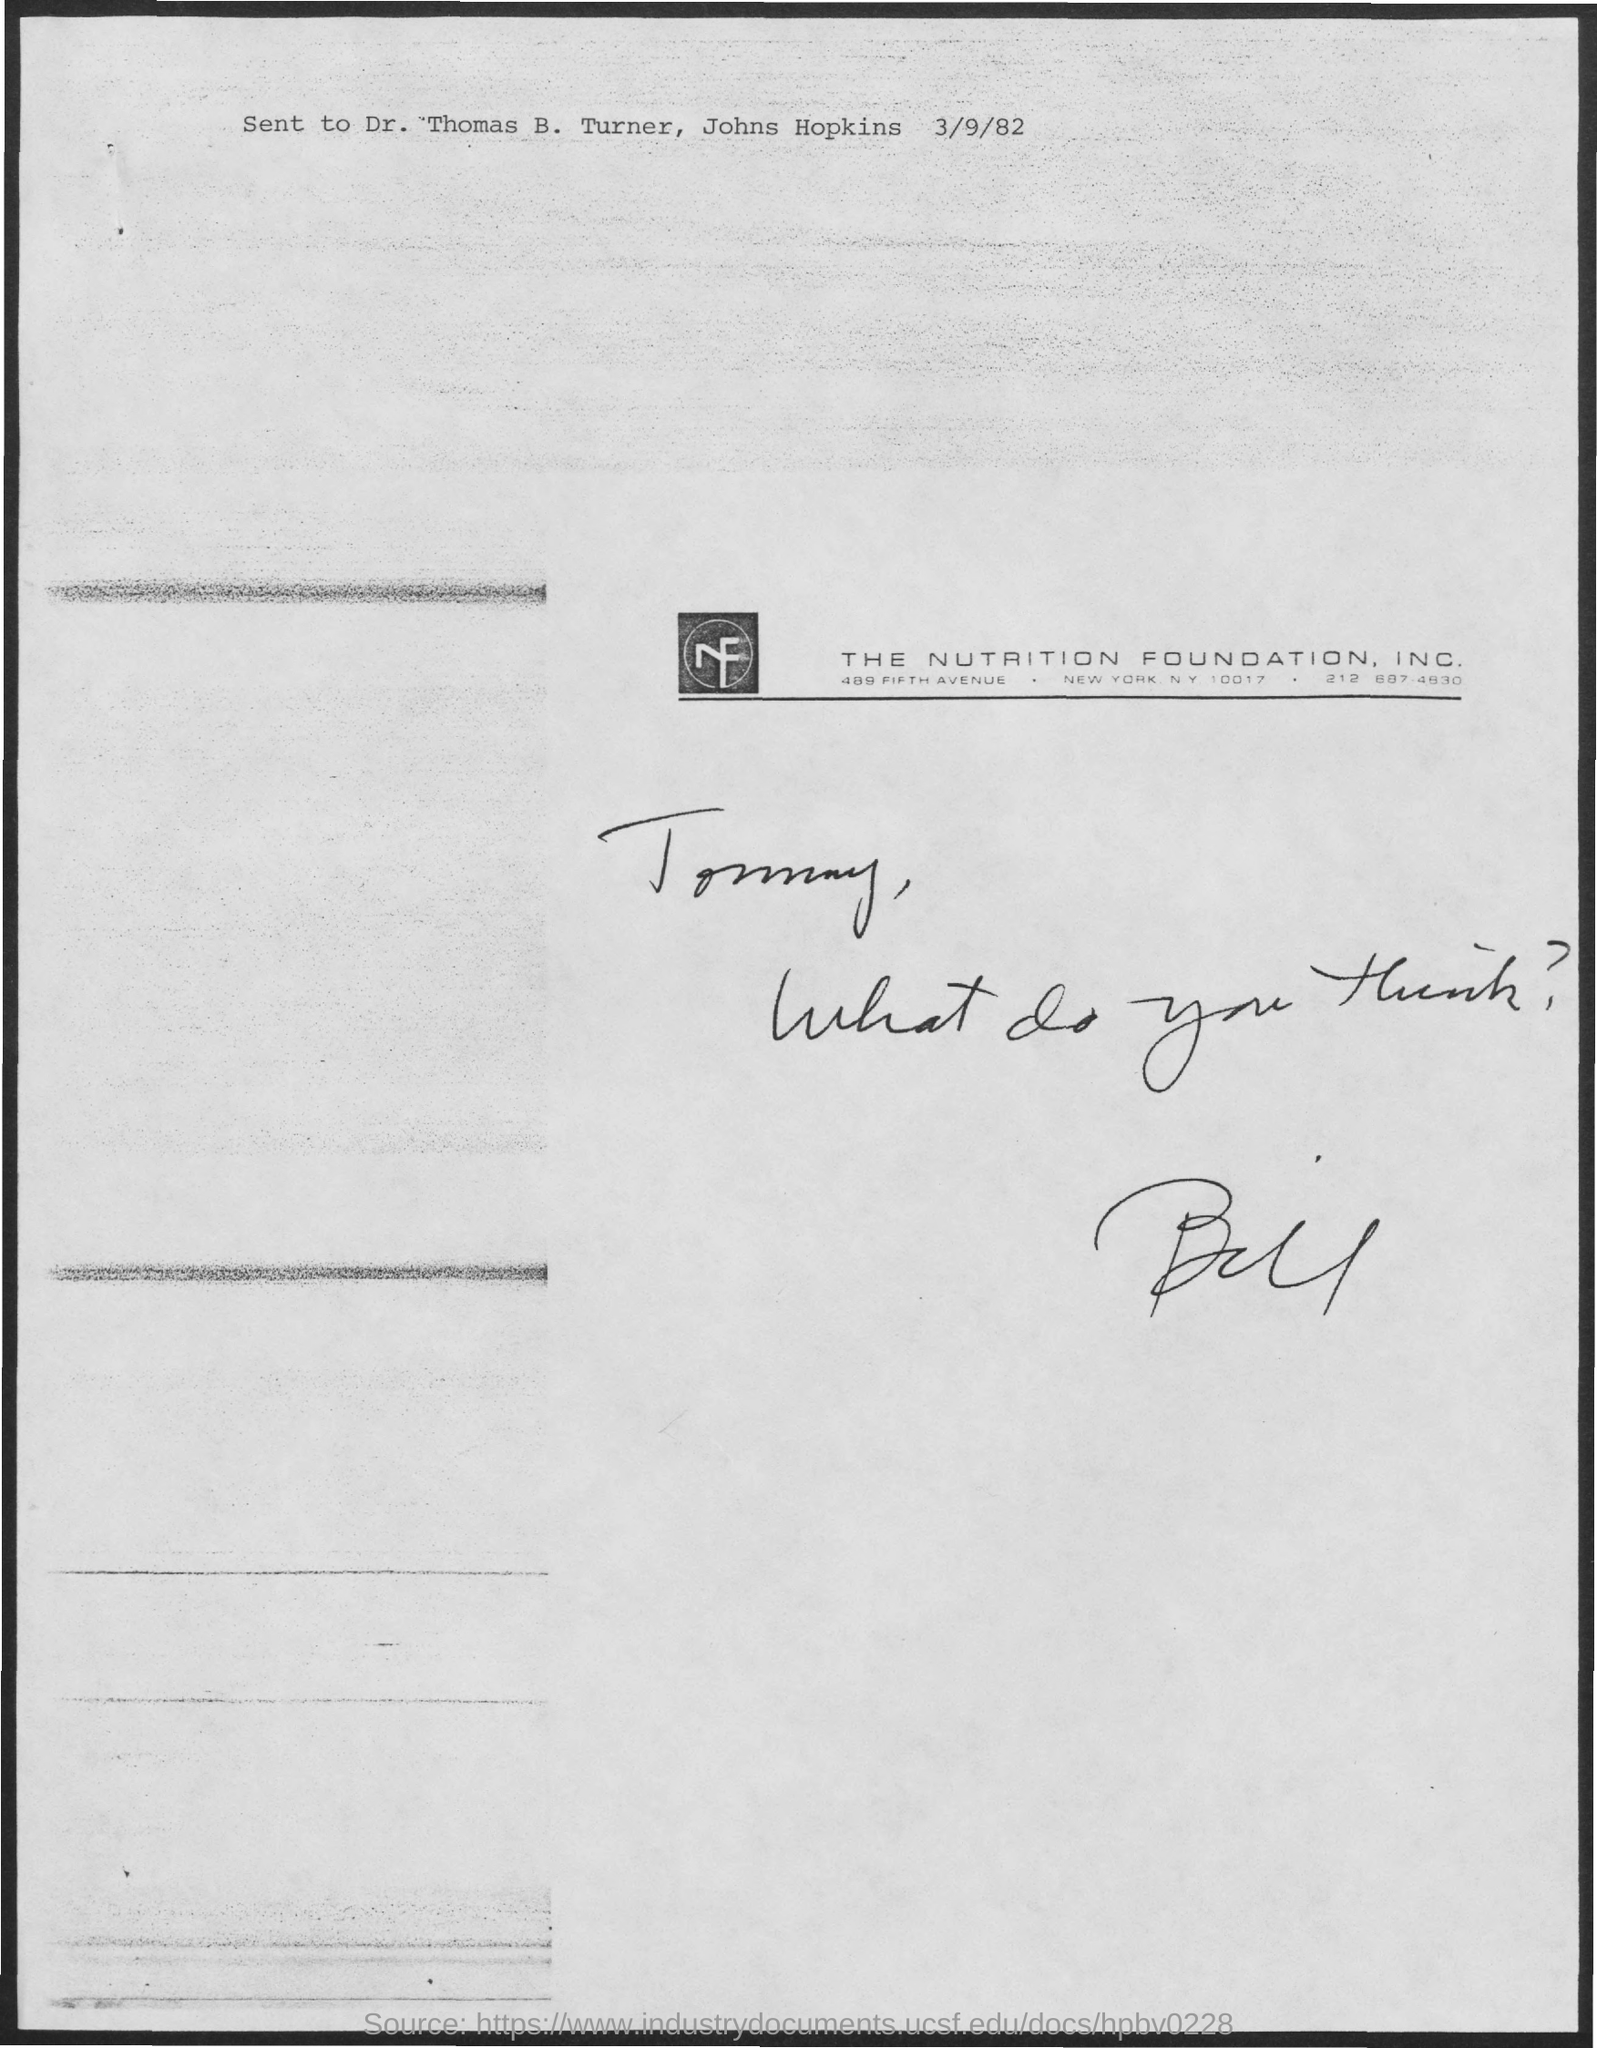Mention a couple of crucial points in this snapshot. The date mentioned in the document is March 9, 1982. 